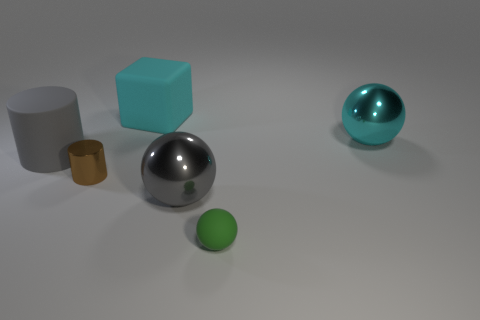What number of cylinders are either small yellow matte things or big gray metal objects?
Ensure brevity in your answer.  0. Are there any big things that have the same shape as the small green rubber thing?
Keep it short and to the point. Yes. The gray rubber object has what shape?
Make the answer very short. Cylinder. What number of objects are either large cyan balls or brown balls?
Make the answer very short. 1. Is the size of the cyan thing on the left side of the cyan metallic object the same as the sphere that is to the left of the green object?
Your response must be concise. Yes. What number of other objects are the same material as the gray sphere?
Your response must be concise. 2. Is the number of big cyan rubber cubes in front of the large gray sphere greater than the number of small matte spheres that are behind the green rubber ball?
Your answer should be very brief. No. What material is the large object left of the cyan block?
Keep it short and to the point. Rubber. Do the green object and the brown thing have the same shape?
Your response must be concise. No. Is there any other thing of the same color as the big block?
Your answer should be compact. Yes. 